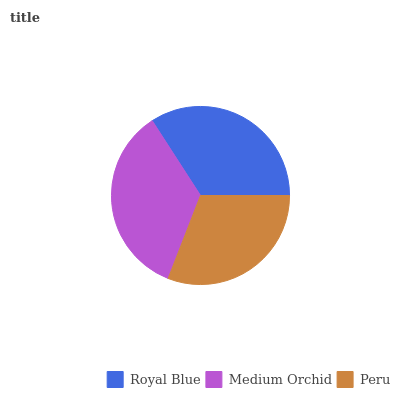Is Peru the minimum?
Answer yes or no. Yes. Is Medium Orchid the maximum?
Answer yes or no. Yes. Is Medium Orchid the minimum?
Answer yes or no. No. Is Peru the maximum?
Answer yes or no. No. Is Medium Orchid greater than Peru?
Answer yes or no. Yes. Is Peru less than Medium Orchid?
Answer yes or no. Yes. Is Peru greater than Medium Orchid?
Answer yes or no. No. Is Medium Orchid less than Peru?
Answer yes or no. No. Is Royal Blue the high median?
Answer yes or no. Yes. Is Royal Blue the low median?
Answer yes or no. Yes. Is Peru the high median?
Answer yes or no. No. Is Peru the low median?
Answer yes or no. No. 